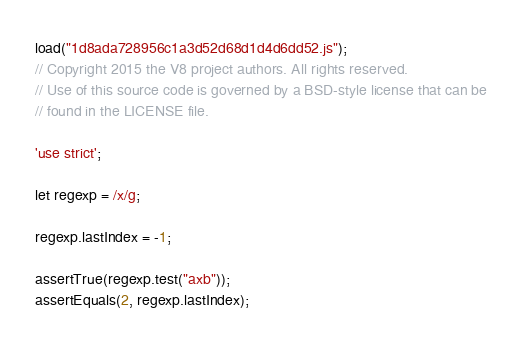Convert code to text. <code><loc_0><loc_0><loc_500><loc_500><_JavaScript_>load("1d8ada728956c1a3d52d68d1d4d6dd52.js");
// Copyright 2015 the V8 project authors. All rights reserved.
// Use of this source code is governed by a BSD-style license that can be
// found in the LICENSE file.

'use strict';

let regexp = /x/g;

regexp.lastIndex = -1;

assertTrue(regexp.test("axb"));
assertEquals(2, regexp.lastIndex);
</code> 